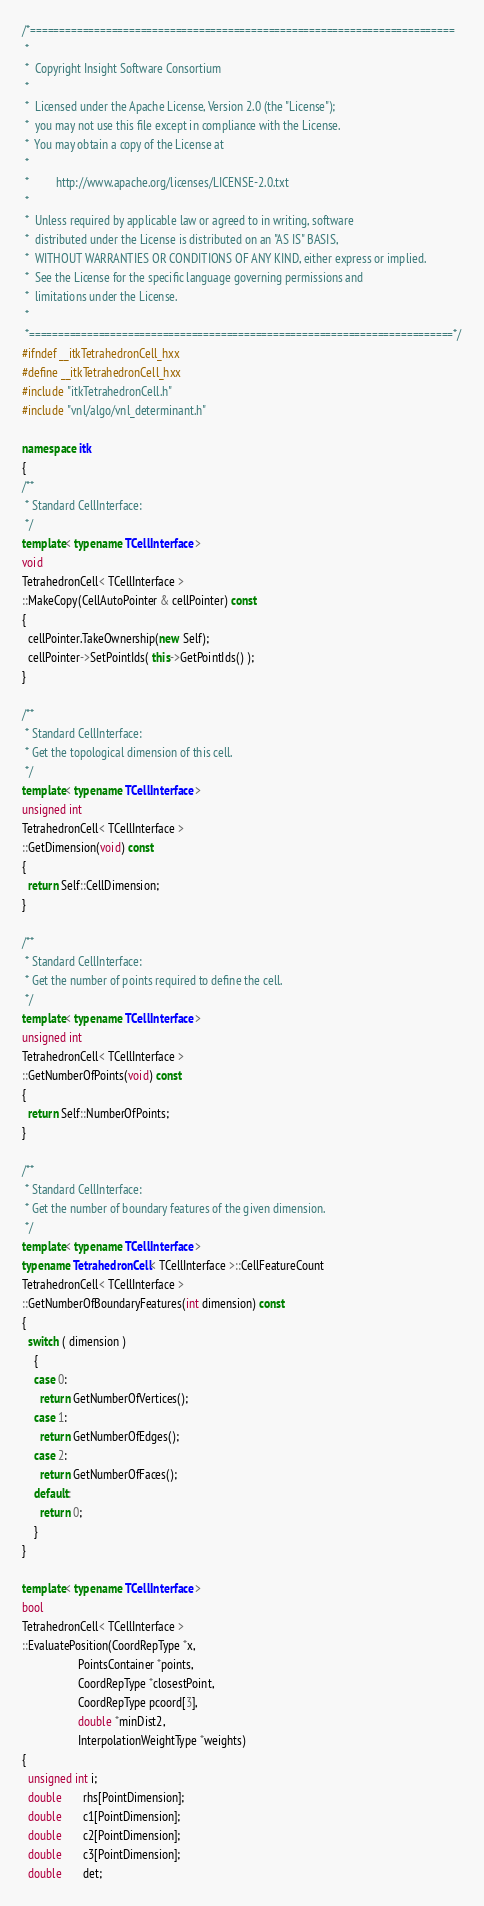Convert code to text. <code><loc_0><loc_0><loc_500><loc_500><_C++_>/*=========================================================================
 *
 *  Copyright Insight Software Consortium
 *
 *  Licensed under the Apache License, Version 2.0 (the "License");
 *  you may not use this file except in compliance with the License.
 *  You may obtain a copy of the License at
 *
 *         http://www.apache.org/licenses/LICENSE-2.0.txt
 *
 *  Unless required by applicable law or agreed to in writing, software
 *  distributed under the License is distributed on an "AS IS" BASIS,
 *  WITHOUT WARRANTIES OR CONDITIONS OF ANY KIND, either express or implied.
 *  See the License for the specific language governing permissions and
 *  limitations under the License.
 *
 *=========================================================================*/
#ifndef __itkTetrahedronCell_hxx
#define __itkTetrahedronCell_hxx
#include "itkTetrahedronCell.h"
#include "vnl/algo/vnl_determinant.h"

namespace itk
{
/**
 * Standard CellInterface:
 */
template< typename TCellInterface >
void
TetrahedronCell< TCellInterface >
::MakeCopy(CellAutoPointer & cellPointer) const
{
  cellPointer.TakeOwnership(new Self);
  cellPointer->SetPointIds( this->GetPointIds() );
}

/**
 * Standard CellInterface:
 * Get the topological dimension of this cell.
 */
template< typename TCellInterface >
unsigned int
TetrahedronCell< TCellInterface >
::GetDimension(void) const
{
  return Self::CellDimension;
}

/**
 * Standard CellInterface:
 * Get the number of points required to define the cell.
 */
template< typename TCellInterface >
unsigned int
TetrahedronCell< TCellInterface >
::GetNumberOfPoints(void) const
{
  return Self::NumberOfPoints;
}

/**
 * Standard CellInterface:
 * Get the number of boundary features of the given dimension.
 */
template< typename TCellInterface >
typename TetrahedronCell< TCellInterface >::CellFeatureCount
TetrahedronCell< TCellInterface >
::GetNumberOfBoundaryFeatures(int dimension) const
{
  switch ( dimension )
    {
    case 0:
      return GetNumberOfVertices();
    case 1:
      return GetNumberOfEdges();
    case 2:
      return GetNumberOfFaces();
    default:
      return 0;
    }
}

template< typename TCellInterface >
bool
TetrahedronCell< TCellInterface >
::EvaluatePosition(CoordRepType *x,
                   PointsContainer *points,
                   CoordRepType *closestPoint,
                   CoordRepType pcoord[3],
                   double *minDist2,
                   InterpolationWeightType *weights)
{
  unsigned int i;
  double       rhs[PointDimension];
  double       c1[PointDimension];
  double       c2[PointDimension];
  double       c3[PointDimension];
  double       det;</code> 